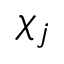Convert formula to latex. <formula><loc_0><loc_0><loc_500><loc_500>\chi _ { j }</formula> 